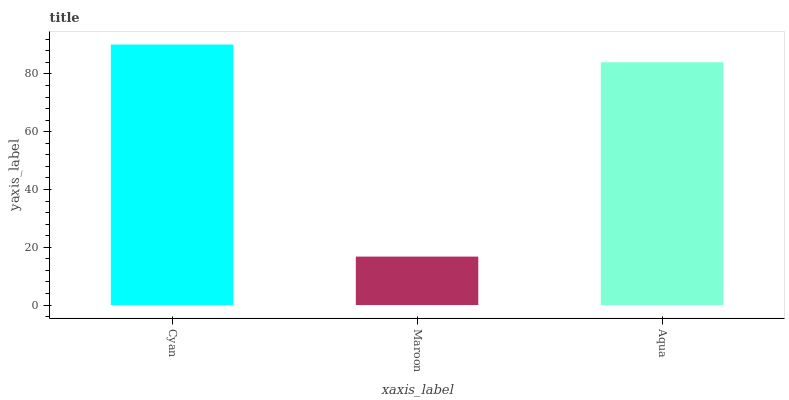Is Maroon the minimum?
Answer yes or no. Yes. Is Cyan the maximum?
Answer yes or no. Yes. Is Aqua the minimum?
Answer yes or no. No. Is Aqua the maximum?
Answer yes or no. No. Is Aqua greater than Maroon?
Answer yes or no. Yes. Is Maroon less than Aqua?
Answer yes or no. Yes. Is Maroon greater than Aqua?
Answer yes or no. No. Is Aqua less than Maroon?
Answer yes or no. No. Is Aqua the high median?
Answer yes or no. Yes. Is Aqua the low median?
Answer yes or no. Yes. Is Maroon the high median?
Answer yes or no. No. Is Cyan the low median?
Answer yes or no. No. 